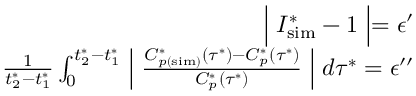Convert formula to latex. <formula><loc_0><loc_0><loc_500><loc_500>\begin{array} { r } { \left | I _ { s i m } ^ { * } - 1 \right | = \epsilon ^ { \prime } } \\ { \frac { 1 } { t _ { 2 } ^ { * } - t _ { 1 } ^ { * } } \int _ { 0 } ^ { t _ { 2 } ^ { * } - t _ { 1 } ^ { * } } \left | \frac { C _ { p ( s i m ) } ^ { * } \left ( \tau ^ { * } \right ) - C _ { p } ^ { * } \left ( \tau ^ { * } \right ) } { C _ { p } ^ { * } \left ( \tau ^ { * } \right ) } \right | d \tau ^ { * } = \epsilon ^ { \prime \prime } } \end{array}</formula> 